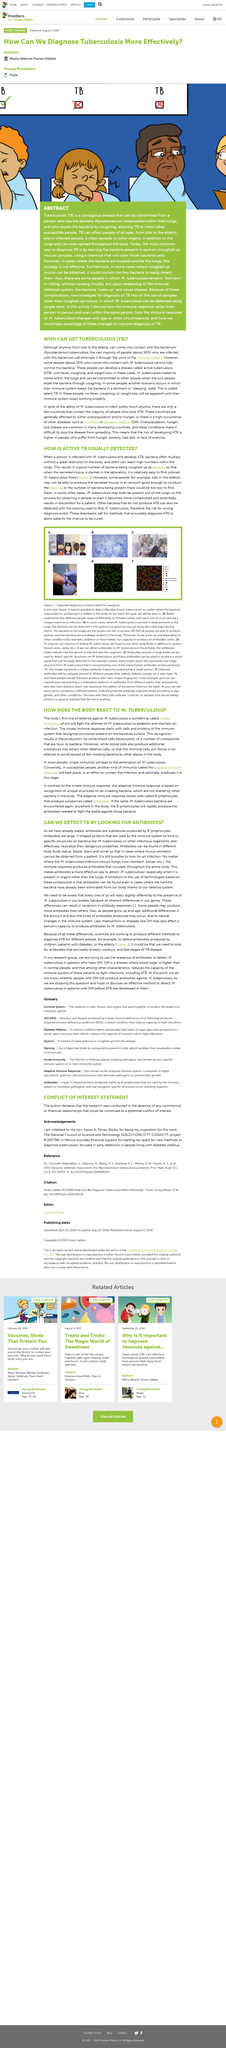Outline some significant characteristics in this image. Approximately 10% of individuals who contract tuberculosis will develop active cases of the disease. Tuberculosis, commonly known as TB, is a disease caused by the bacterium Mycobacterium tuberculosis. Innate immunity will attempt to combat the efforts of M.Tuberculosis to establish and maintain an infection in the body. The body's first line of defense against M.Tuberculosis is innate immunity, which is a rapid and nonspecific response to invaders such as Mycobacterium tuberculosis. Leukocytes, commonly referred to as white blood cells, are vital components of the immune system that help protect the body against foreign invaders such as bacteria, viruses, and other pathogens. 